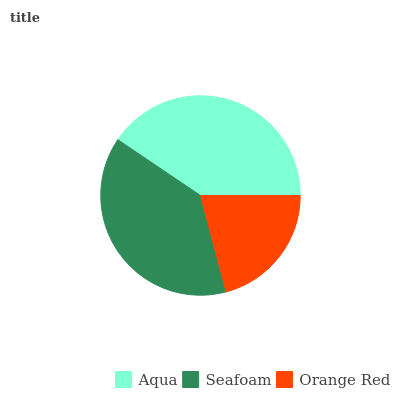Is Orange Red the minimum?
Answer yes or no. Yes. Is Aqua the maximum?
Answer yes or no. Yes. Is Seafoam the minimum?
Answer yes or no. No. Is Seafoam the maximum?
Answer yes or no. No. Is Aqua greater than Seafoam?
Answer yes or no. Yes. Is Seafoam less than Aqua?
Answer yes or no. Yes. Is Seafoam greater than Aqua?
Answer yes or no. No. Is Aqua less than Seafoam?
Answer yes or no. No. Is Seafoam the high median?
Answer yes or no. Yes. Is Seafoam the low median?
Answer yes or no. Yes. Is Orange Red the high median?
Answer yes or no. No. Is Orange Red the low median?
Answer yes or no. No. 